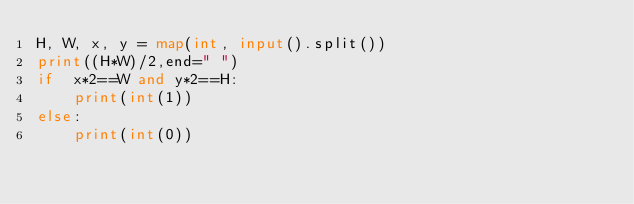<code> <loc_0><loc_0><loc_500><loc_500><_Python_>H, W, x, y = map(int, input().split())
print((H*W)/2,end=" ")
if  x*2==W and y*2==H:
	print(int(1))
else:
	print(int(0))
</code> 